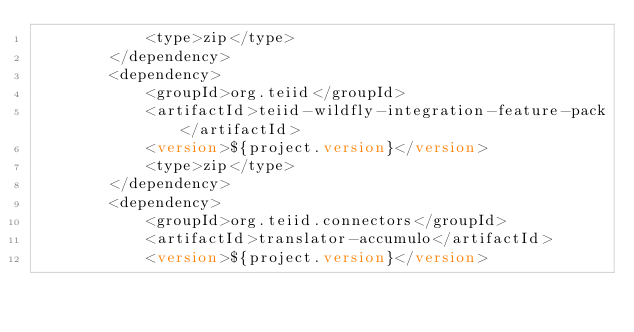<code> <loc_0><loc_0><loc_500><loc_500><_XML_>            <type>zip</type>
        </dependency>
        <dependency>
            <groupId>org.teiid</groupId>
            <artifactId>teiid-wildfly-integration-feature-pack</artifactId>
            <version>${project.version}</version>
            <type>zip</type>
        </dependency>
        <dependency>
            <groupId>org.teiid.connectors</groupId>
            <artifactId>translator-accumulo</artifactId>
            <version>${project.version}</version></code> 